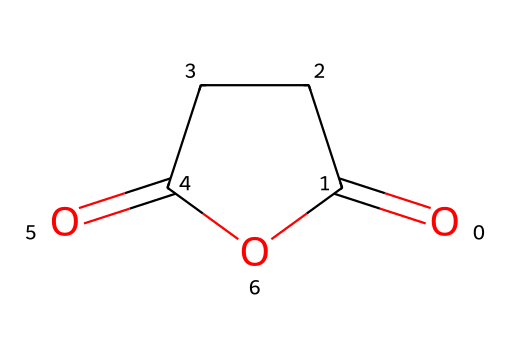What is the molecular formula of succinic anhydride? To determine the molecular formula, we can analyze the structure based on the SMILES representation. The structure indicates there are four carbon atoms, four oxygen atoms, and six hydrogen atoms, which leads us to the formula C4H4O3.
Answer: C4H4O3 How many carbon atoms are present in this chemical? By examining the SMILES representation and counting the 'C' symbols, we find there are four carbon atoms in the structure of succinic anhydride.
Answer: four What type of functional group is represented in succinic anhydride? The presence of the anhydride structure, indicated by the two carbonyl (C=O) groups adjacent to each other and connected through an oxygen atom, shows that succinic anhydride belongs to the anhydride functional group category.
Answer: anhydride What is the total number of rings present in this chemical structure? The visual representation reveals that succinic anhydride has a cyclic structure, specifically a five-membered ring including two carbonyl groups and one ether linkage, thus confirming the presence of one ring.
Answer: one Does succinic anhydride react with water? Anhydrides typically react with water in a hydrolysis reaction to form the corresponding acids; therefore, succinic anhydride will indeed react with water to yield succinic acid.
Answer: yes Is succinic anhydride a solid or a liquid at room temperature? The properties of succinic anhydride suggest that it is a solid substance at room temperature, as indicated by its melting point and common physical state.
Answer: solid What is the appearance of succinic anhydride? Upon examining succinic anhydride, it is known to have a white crystalline appearance in its solid form, which can be inferred from typical descriptions and data.
Answer: white crystalline 